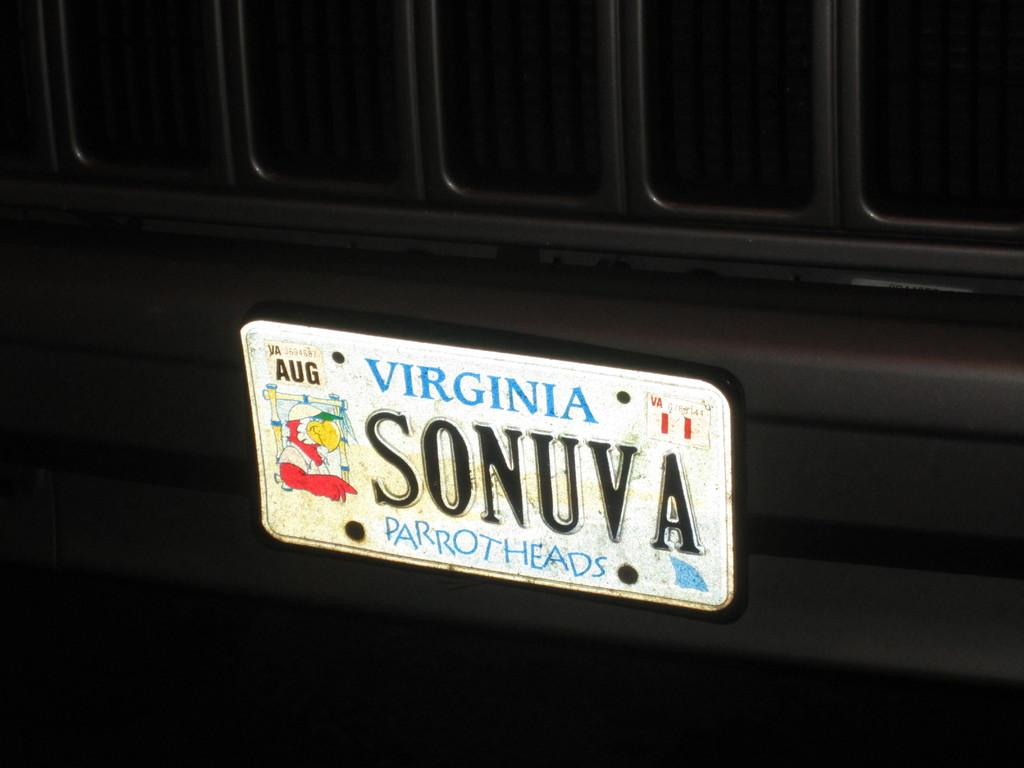<image>
Summarize the visual content of the image. the word Virginia is on the back of a car 